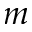Convert formula to latex. <formula><loc_0><loc_0><loc_500><loc_500>m</formula> 